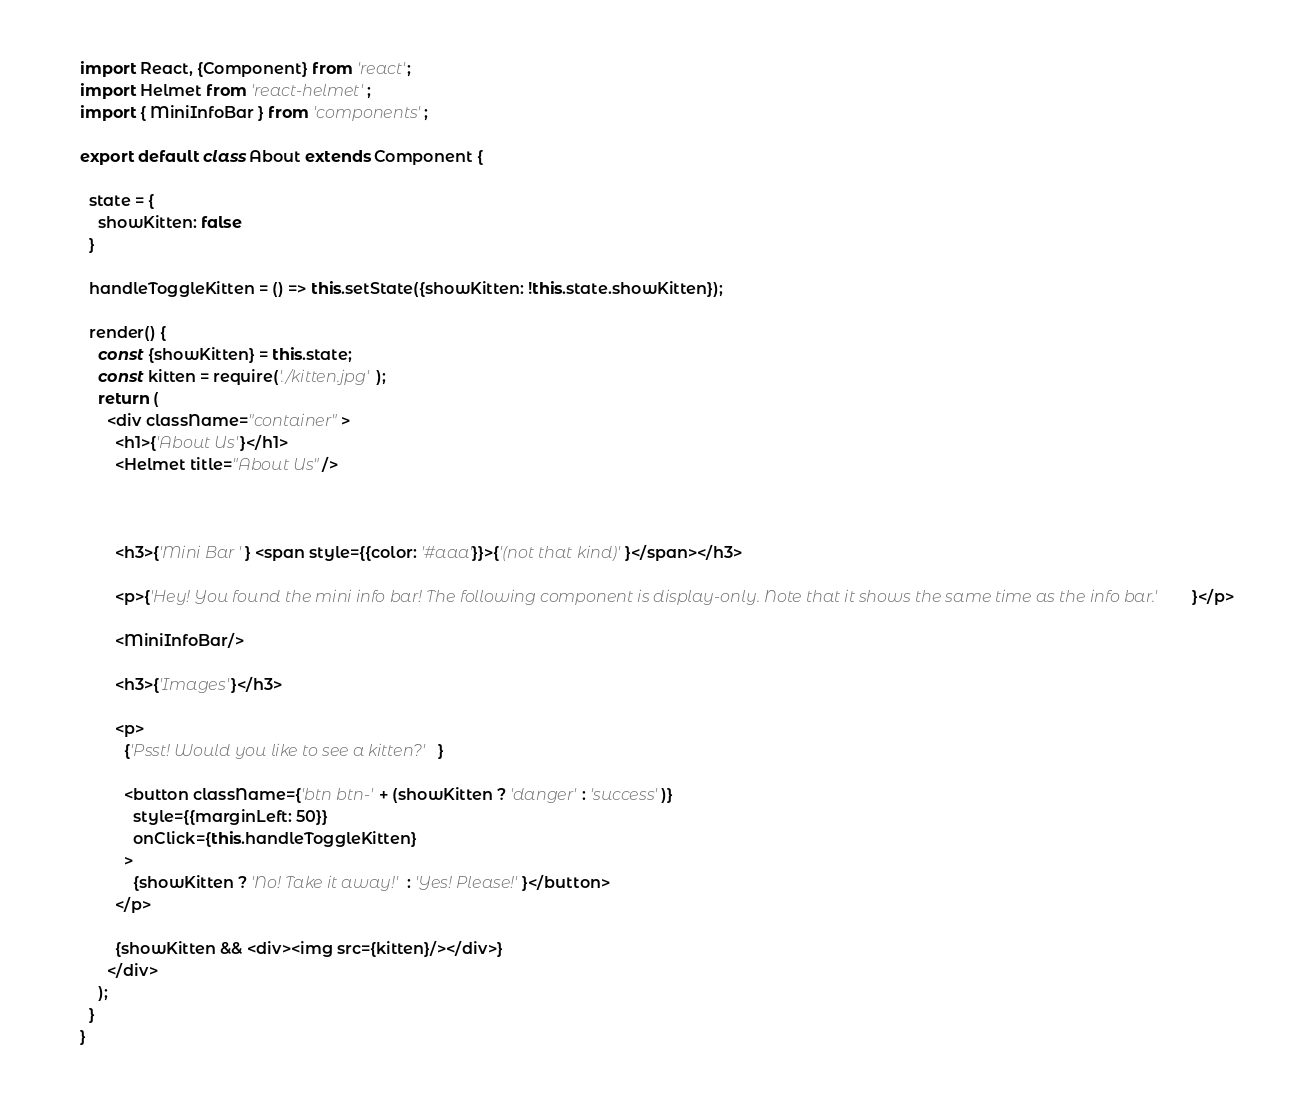<code> <loc_0><loc_0><loc_500><loc_500><_JavaScript_>import React, {Component} from 'react';
import Helmet from 'react-helmet';
import { MiniInfoBar } from 'components';

export default class About extends Component {

  state = {
    showKitten: false
  }

  handleToggleKitten = () => this.setState({showKitten: !this.state.showKitten});

  render() {
    const {showKitten} = this.state;
    const kitten = require('./kitten.jpg');
    return (
      <div className="container">
        <h1>{'About Us'}</h1>
        <Helmet title="About Us"/>



        <h3>{'Mini Bar '} <span style={{color: '#aaa'}}>{'(not that kind)'}</span></h3>

        <p>{'Hey! You found the mini info bar! The following component is display-only. Note that it shows the same time as the info bar.'}</p>

        <MiniInfoBar/>

        <h3>{'Images'}</h3>

        <p>
          {'Psst! Would you like to see a kitten?'}

          <button className={'btn btn-' + (showKitten ? 'danger' : 'success')}
            style={{marginLeft: 50}}
            onClick={this.handleToggleKitten}
          >
            {showKitten ? 'No! Take it away!' : 'Yes! Please!'}</button>
        </p>

        {showKitten && <div><img src={kitten}/></div>}
      </div>
    );
  }
}
</code> 